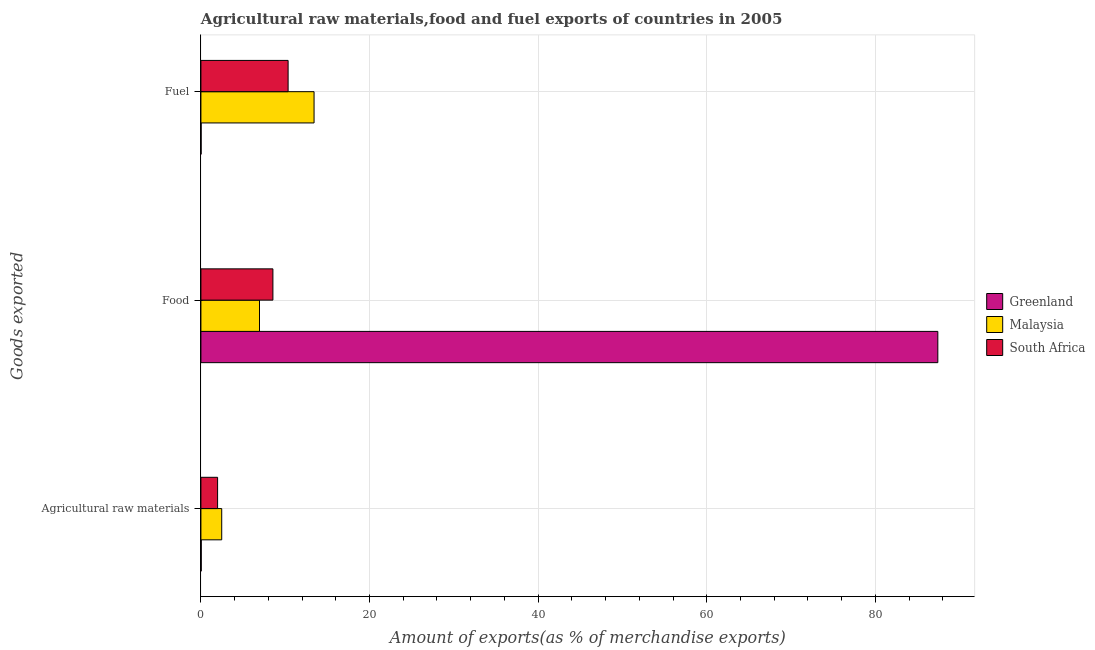How many groups of bars are there?
Your response must be concise. 3. Are the number of bars per tick equal to the number of legend labels?
Ensure brevity in your answer.  Yes. How many bars are there on the 2nd tick from the top?
Provide a succinct answer. 3. How many bars are there on the 2nd tick from the bottom?
Make the answer very short. 3. What is the label of the 1st group of bars from the top?
Your response must be concise. Fuel. What is the percentage of food exports in South Africa?
Your response must be concise. 8.54. Across all countries, what is the maximum percentage of raw materials exports?
Keep it short and to the point. 2.47. Across all countries, what is the minimum percentage of fuel exports?
Provide a short and direct response. 0.02. In which country was the percentage of food exports maximum?
Offer a terse response. Greenland. In which country was the percentage of fuel exports minimum?
Provide a short and direct response. Greenland. What is the total percentage of food exports in the graph?
Give a very brief answer. 102.9. What is the difference between the percentage of raw materials exports in Malaysia and that in Greenland?
Keep it short and to the point. 2.43. What is the difference between the percentage of food exports in Malaysia and the percentage of raw materials exports in Greenland?
Offer a terse response. 6.91. What is the average percentage of fuel exports per country?
Offer a very short reply. 7.93. What is the difference between the percentage of raw materials exports and percentage of fuel exports in Malaysia?
Your response must be concise. -10.95. In how many countries, is the percentage of food exports greater than 36 %?
Offer a terse response. 1. What is the ratio of the percentage of food exports in South Africa to that in Greenland?
Offer a terse response. 0.1. What is the difference between the highest and the second highest percentage of raw materials exports?
Your response must be concise. 0.49. What is the difference between the highest and the lowest percentage of raw materials exports?
Provide a short and direct response. 2.43. What does the 2nd bar from the top in Fuel represents?
Offer a very short reply. Malaysia. What does the 2nd bar from the bottom in Fuel represents?
Provide a succinct answer. Malaysia. Is it the case that in every country, the sum of the percentage of raw materials exports and percentage of food exports is greater than the percentage of fuel exports?
Ensure brevity in your answer.  No. How many countries are there in the graph?
Your response must be concise. 3. Are the values on the major ticks of X-axis written in scientific E-notation?
Keep it short and to the point. No. Does the graph contain grids?
Provide a short and direct response. Yes. How are the legend labels stacked?
Give a very brief answer. Vertical. What is the title of the graph?
Keep it short and to the point. Agricultural raw materials,food and fuel exports of countries in 2005. What is the label or title of the X-axis?
Keep it short and to the point. Amount of exports(as % of merchandise exports). What is the label or title of the Y-axis?
Offer a very short reply. Goods exported. What is the Amount of exports(as % of merchandise exports) in Greenland in Agricultural raw materials?
Your answer should be compact. 0.04. What is the Amount of exports(as % of merchandise exports) in Malaysia in Agricultural raw materials?
Your response must be concise. 2.47. What is the Amount of exports(as % of merchandise exports) of South Africa in Agricultural raw materials?
Provide a succinct answer. 1.98. What is the Amount of exports(as % of merchandise exports) of Greenland in Food?
Give a very brief answer. 87.41. What is the Amount of exports(as % of merchandise exports) of Malaysia in Food?
Give a very brief answer. 6.95. What is the Amount of exports(as % of merchandise exports) in South Africa in Food?
Ensure brevity in your answer.  8.54. What is the Amount of exports(as % of merchandise exports) in Greenland in Fuel?
Provide a succinct answer. 0.02. What is the Amount of exports(as % of merchandise exports) of Malaysia in Fuel?
Give a very brief answer. 13.42. What is the Amount of exports(as % of merchandise exports) of South Africa in Fuel?
Give a very brief answer. 10.34. Across all Goods exported, what is the maximum Amount of exports(as % of merchandise exports) in Greenland?
Keep it short and to the point. 87.41. Across all Goods exported, what is the maximum Amount of exports(as % of merchandise exports) in Malaysia?
Ensure brevity in your answer.  13.42. Across all Goods exported, what is the maximum Amount of exports(as % of merchandise exports) of South Africa?
Give a very brief answer. 10.34. Across all Goods exported, what is the minimum Amount of exports(as % of merchandise exports) of Greenland?
Give a very brief answer. 0.02. Across all Goods exported, what is the minimum Amount of exports(as % of merchandise exports) of Malaysia?
Your answer should be compact. 2.47. Across all Goods exported, what is the minimum Amount of exports(as % of merchandise exports) of South Africa?
Your answer should be compact. 1.98. What is the total Amount of exports(as % of merchandise exports) in Greenland in the graph?
Offer a very short reply. 87.47. What is the total Amount of exports(as % of merchandise exports) of Malaysia in the graph?
Provide a short and direct response. 22.84. What is the total Amount of exports(as % of merchandise exports) of South Africa in the graph?
Provide a short and direct response. 20.86. What is the difference between the Amount of exports(as % of merchandise exports) of Greenland in Agricultural raw materials and that in Food?
Make the answer very short. -87.37. What is the difference between the Amount of exports(as % of merchandise exports) of Malaysia in Agricultural raw materials and that in Food?
Offer a terse response. -4.48. What is the difference between the Amount of exports(as % of merchandise exports) of South Africa in Agricultural raw materials and that in Food?
Ensure brevity in your answer.  -6.56. What is the difference between the Amount of exports(as % of merchandise exports) in Greenland in Agricultural raw materials and that in Fuel?
Offer a very short reply. 0.02. What is the difference between the Amount of exports(as % of merchandise exports) of Malaysia in Agricultural raw materials and that in Fuel?
Your response must be concise. -10.95. What is the difference between the Amount of exports(as % of merchandise exports) in South Africa in Agricultural raw materials and that in Fuel?
Your answer should be compact. -8.37. What is the difference between the Amount of exports(as % of merchandise exports) in Greenland in Food and that in Fuel?
Make the answer very short. 87.39. What is the difference between the Amount of exports(as % of merchandise exports) in Malaysia in Food and that in Fuel?
Offer a terse response. -6.47. What is the difference between the Amount of exports(as % of merchandise exports) of South Africa in Food and that in Fuel?
Your answer should be very brief. -1.8. What is the difference between the Amount of exports(as % of merchandise exports) of Greenland in Agricultural raw materials and the Amount of exports(as % of merchandise exports) of Malaysia in Food?
Provide a short and direct response. -6.91. What is the difference between the Amount of exports(as % of merchandise exports) of Greenland in Agricultural raw materials and the Amount of exports(as % of merchandise exports) of South Africa in Food?
Offer a terse response. -8.5. What is the difference between the Amount of exports(as % of merchandise exports) in Malaysia in Agricultural raw materials and the Amount of exports(as % of merchandise exports) in South Africa in Food?
Offer a very short reply. -6.07. What is the difference between the Amount of exports(as % of merchandise exports) of Greenland in Agricultural raw materials and the Amount of exports(as % of merchandise exports) of Malaysia in Fuel?
Your response must be concise. -13.38. What is the difference between the Amount of exports(as % of merchandise exports) of Greenland in Agricultural raw materials and the Amount of exports(as % of merchandise exports) of South Africa in Fuel?
Your answer should be compact. -10.31. What is the difference between the Amount of exports(as % of merchandise exports) in Malaysia in Agricultural raw materials and the Amount of exports(as % of merchandise exports) in South Africa in Fuel?
Ensure brevity in your answer.  -7.88. What is the difference between the Amount of exports(as % of merchandise exports) of Greenland in Food and the Amount of exports(as % of merchandise exports) of Malaysia in Fuel?
Your answer should be compact. 73.99. What is the difference between the Amount of exports(as % of merchandise exports) of Greenland in Food and the Amount of exports(as % of merchandise exports) of South Africa in Fuel?
Keep it short and to the point. 77.07. What is the difference between the Amount of exports(as % of merchandise exports) in Malaysia in Food and the Amount of exports(as % of merchandise exports) in South Africa in Fuel?
Offer a very short reply. -3.39. What is the average Amount of exports(as % of merchandise exports) in Greenland per Goods exported?
Make the answer very short. 29.16. What is the average Amount of exports(as % of merchandise exports) in Malaysia per Goods exported?
Provide a short and direct response. 7.61. What is the average Amount of exports(as % of merchandise exports) of South Africa per Goods exported?
Make the answer very short. 6.95. What is the difference between the Amount of exports(as % of merchandise exports) in Greenland and Amount of exports(as % of merchandise exports) in Malaysia in Agricultural raw materials?
Keep it short and to the point. -2.43. What is the difference between the Amount of exports(as % of merchandise exports) of Greenland and Amount of exports(as % of merchandise exports) of South Africa in Agricultural raw materials?
Your answer should be very brief. -1.94. What is the difference between the Amount of exports(as % of merchandise exports) in Malaysia and Amount of exports(as % of merchandise exports) in South Africa in Agricultural raw materials?
Keep it short and to the point. 0.49. What is the difference between the Amount of exports(as % of merchandise exports) in Greenland and Amount of exports(as % of merchandise exports) in Malaysia in Food?
Provide a short and direct response. 80.46. What is the difference between the Amount of exports(as % of merchandise exports) of Greenland and Amount of exports(as % of merchandise exports) of South Africa in Food?
Your answer should be compact. 78.87. What is the difference between the Amount of exports(as % of merchandise exports) in Malaysia and Amount of exports(as % of merchandise exports) in South Africa in Food?
Offer a terse response. -1.59. What is the difference between the Amount of exports(as % of merchandise exports) of Greenland and Amount of exports(as % of merchandise exports) of Malaysia in Fuel?
Give a very brief answer. -13.4. What is the difference between the Amount of exports(as % of merchandise exports) of Greenland and Amount of exports(as % of merchandise exports) of South Africa in Fuel?
Keep it short and to the point. -10.32. What is the difference between the Amount of exports(as % of merchandise exports) of Malaysia and Amount of exports(as % of merchandise exports) of South Africa in Fuel?
Give a very brief answer. 3.08. What is the ratio of the Amount of exports(as % of merchandise exports) of Malaysia in Agricultural raw materials to that in Food?
Provide a succinct answer. 0.35. What is the ratio of the Amount of exports(as % of merchandise exports) in South Africa in Agricultural raw materials to that in Food?
Your answer should be very brief. 0.23. What is the ratio of the Amount of exports(as % of merchandise exports) in Greenland in Agricultural raw materials to that in Fuel?
Ensure brevity in your answer.  1.69. What is the ratio of the Amount of exports(as % of merchandise exports) of Malaysia in Agricultural raw materials to that in Fuel?
Give a very brief answer. 0.18. What is the ratio of the Amount of exports(as % of merchandise exports) in South Africa in Agricultural raw materials to that in Fuel?
Make the answer very short. 0.19. What is the ratio of the Amount of exports(as % of merchandise exports) in Greenland in Food to that in Fuel?
Provide a short and direct response. 3943.47. What is the ratio of the Amount of exports(as % of merchandise exports) in Malaysia in Food to that in Fuel?
Your response must be concise. 0.52. What is the ratio of the Amount of exports(as % of merchandise exports) in South Africa in Food to that in Fuel?
Ensure brevity in your answer.  0.83. What is the difference between the highest and the second highest Amount of exports(as % of merchandise exports) in Greenland?
Your response must be concise. 87.37. What is the difference between the highest and the second highest Amount of exports(as % of merchandise exports) in Malaysia?
Offer a very short reply. 6.47. What is the difference between the highest and the second highest Amount of exports(as % of merchandise exports) in South Africa?
Keep it short and to the point. 1.8. What is the difference between the highest and the lowest Amount of exports(as % of merchandise exports) of Greenland?
Provide a short and direct response. 87.39. What is the difference between the highest and the lowest Amount of exports(as % of merchandise exports) in Malaysia?
Provide a succinct answer. 10.95. What is the difference between the highest and the lowest Amount of exports(as % of merchandise exports) of South Africa?
Offer a very short reply. 8.37. 